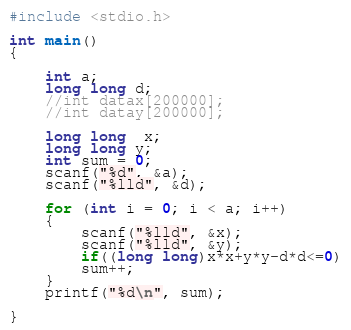<code> <loc_0><loc_0><loc_500><loc_500><_C_>#include <stdio.h>

int main()
{

    int a;
    long long d;
    //int datax[200000];
    //int datay[200000];

    long long  x;
    long long y;
    int sum = 0;
    scanf("%d", &a);
    scanf("%lld", &d);

    for (int i = 0; i < a; i++)
    {
        scanf("%lld", &x);
        scanf("%lld", &y);
        if((long long)x*x+y*y-d*d<=0)
        sum++;
    }
    printf("%d\n", sum);

}</code> 